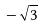Convert formula to latex. <formula><loc_0><loc_0><loc_500><loc_500>- \sqrt { 3 }</formula> 